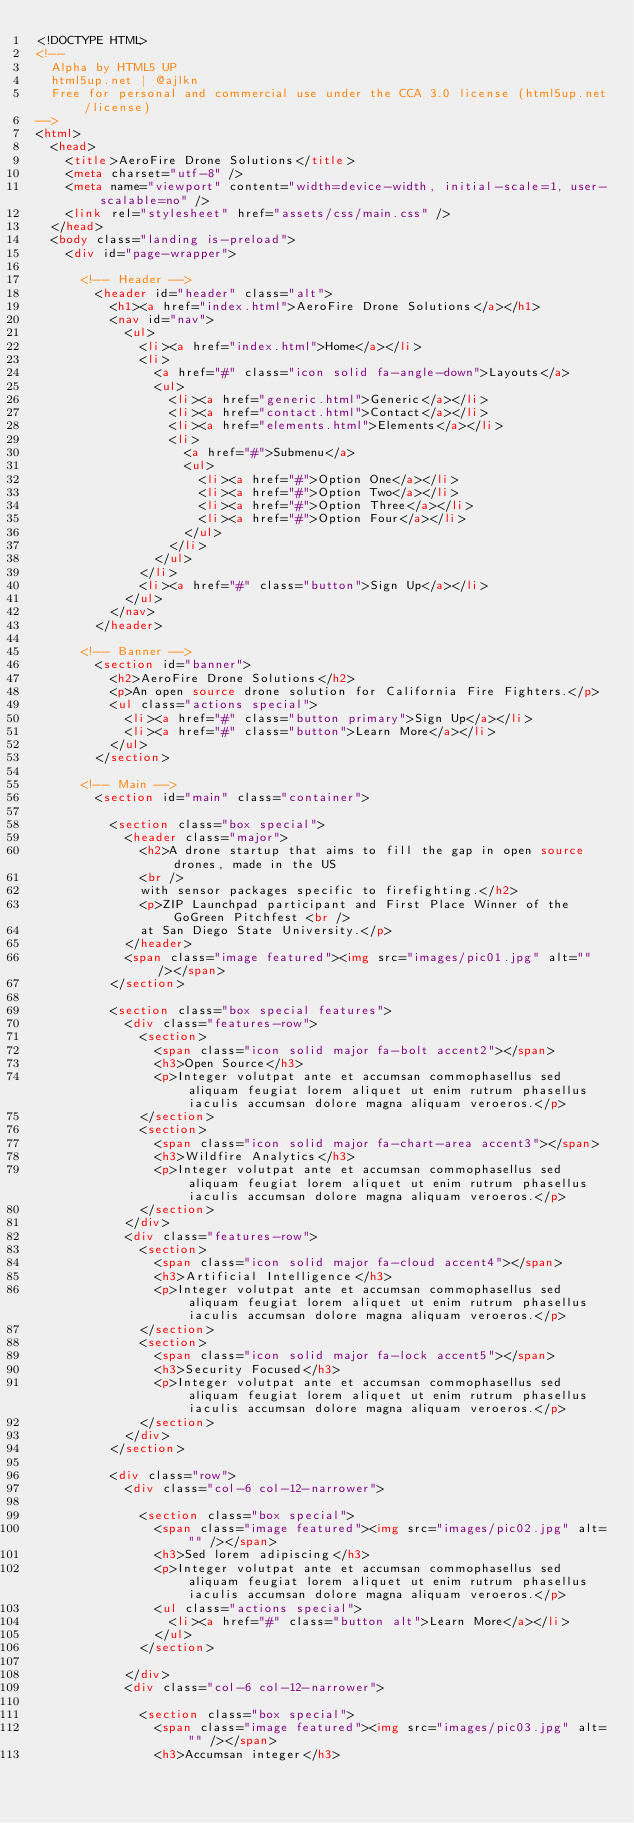Convert code to text. <code><loc_0><loc_0><loc_500><loc_500><_HTML_><!DOCTYPE HTML>
<!--
	Alpha by HTML5 UP
	html5up.net | @ajlkn
	Free for personal and commercial use under the CCA 3.0 license (html5up.net/license)
-->
<html>
	<head>
		<title>AeroFire Drone Solutions</title>
		<meta charset="utf-8" />
		<meta name="viewport" content="width=device-width, initial-scale=1, user-scalable=no" />
		<link rel="stylesheet" href="assets/css/main.css" />
	</head>
	<body class="landing is-preload">
		<div id="page-wrapper">

			<!-- Header -->
				<header id="header" class="alt">
					<h1><a href="index.html">AeroFire Drone Solutions</a></h1>
					<nav id="nav">
						<ul>
							<li><a href="index.html">Home</a></li>
							<li>
								<a href="#" class="icon solid fa-angle-down">Layouts</a>
								<ul>
									<li><a href="generic.html">Generic</a></li>
									<li><a href="contact.html">Contact</a></li>
									<li><a href="elements.html">Elements</a></li>
									<li>
										<a href="#">Submenu</a>
										<ul>
											<li><a href="#">Option One</a></li>
											<li><a href="#">Option Two</a></li>
											<li><a href="#">Option Three</a></li>
											<li><a href="#">Option Four</a></li>
										</ul>
									</li>
								</ul>
							</li>
							<li><a href="#" class="button">Sign Up</a></li>
						</ul>
					</nav>
				</header>

			<!-- Banner -->
				<section id="banner">
					<h2>AeroFire Drone Solutions</h2>
					<p>An open source drone solution for California Fire Fighters.</p>
					<ul class="actions special">
						<li><a href="#" class="button primary">Sign Up</a></li>
						<li><a href="#" class="button">Learn More</a></li>
					</ul>
				</section>

			<!-- Main -->
				<section id="main" class="container">

					<section class="box special">
						<header class="major">
							<h2>A drone startup that aims to fill the gap in open source drones, made in the US
							<br />
							with sensor packages specific to firefighting.</h2>
							<p>ZIP Launchpad participant and First Place Winner of the GoGreen Pitchfest <br />
							at San Diego State University.</p>
						</header>
						<span class="image featured"><img src="images/pic01.jpg" alt="" /></span>
					</section>

					<section class="box special features">
						<div class="features-row">
							<section>
								<span class="icon solid major fa-bolt accent2"></span>
								<h3>Open Source</h3>
								<p>Integer volutpat ante et accumsan commophasellus sed aliquam feugiat lorem aliquet ut enim rutrum phasellus iaculis accumsan dolore magna aliquam veroeros.</p>
							</section>
							<section>
								<span class="icon solid major fa-chart-area accent3"></span>
								<h3>Wildfire Analytics</h3>
								<p>Integer volutpat ante et accumsan commophasellus sed aliquam feugiat lorem aliquet ut enim rutrum phasellus iaculis accumsan dolore magna aliquam veroeros.</p>
							</section>
						</div>
						<div class="features-row">
							<section>
								<span class="icon solid major fa-cloud accent4"></span>
								<h3>Artificial Intelligence</h3>
								<p>Integer volutpat ante et accumsan commophasellus sed aliquam feugiat lorem aliquet ut enim rutrum phasellus iaculis accumsan dolore magna aliquam veroeros.</p>
							</section>
							<section>
								<span class="icon solid major fa-lock accent5"></span>
								<h3>Security Focused</h3>
								<p>Integer volutpat ante et accumsan commophasellus sed aliquam feugiat lorem aliquet ut enim rutrum phasellus iaculis accumsan dolore magna aliquam veroeros.</p>
							</section>
						</div>
					</section>

					<div class="row">
						<div class="col-6 col-12-narrower">

							<section class="box special">
								<span class="image featured"><img src="images/pic02.jpg" alt="" /></span>
								<h3>Sed lorem adipiscing</h3>
								<p>Integer volutpat ante et accumsan commophasellus sed aliquam feugiat lorem aliquet ut enim rutrum phasellus iaculis accumsan dolore magna aliquam veroeros.</p>
								<ul class="actions special">
									<li><a href="#" class="button alt">Learn More</a></li>
								</ul>
							</section>

						</div>
						<div class="col-6 col-12-narrower">

							<section class="box special">
								<span class="image featured"><img src="images/pic03.jpg" alt="" /></span>
								<h3>Accumsan integer</h3></code> 